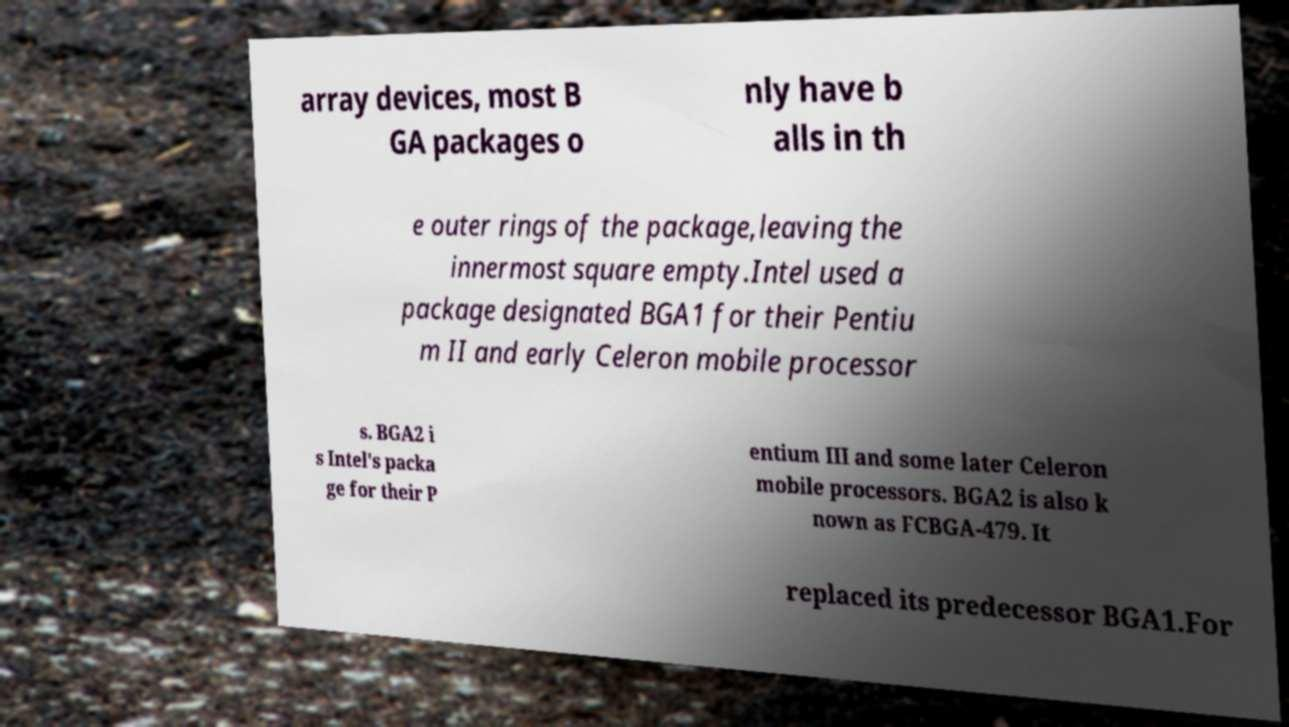I need the written content from this picture converted into text. Can you do that? array devices, most B GA packages o nly have b alls in th e outer rings of the package,leaving the innermost square empty.Intel used a package designated BGA1 for their Pentiu m II and early Celeron mobile processor s. BGA2 i s Intel's packa ge for their P entium III and some later Celeron mobile processors. BGA2 is also k nown as FCBGA-479. It replaced its predecessor BGA1.For 